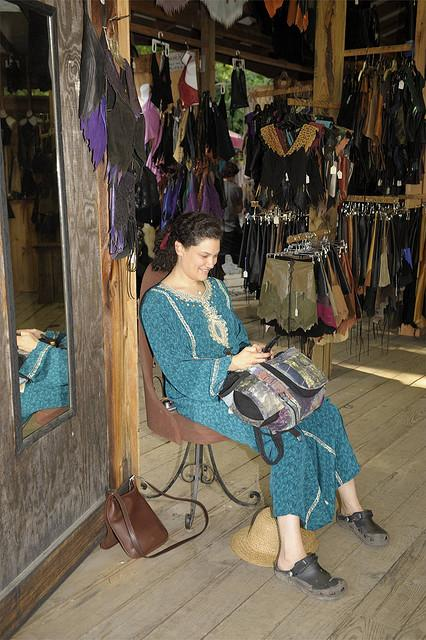What's the lady doing?

Choices:
A) eating
B) reading
C) texting
D) playing texting 